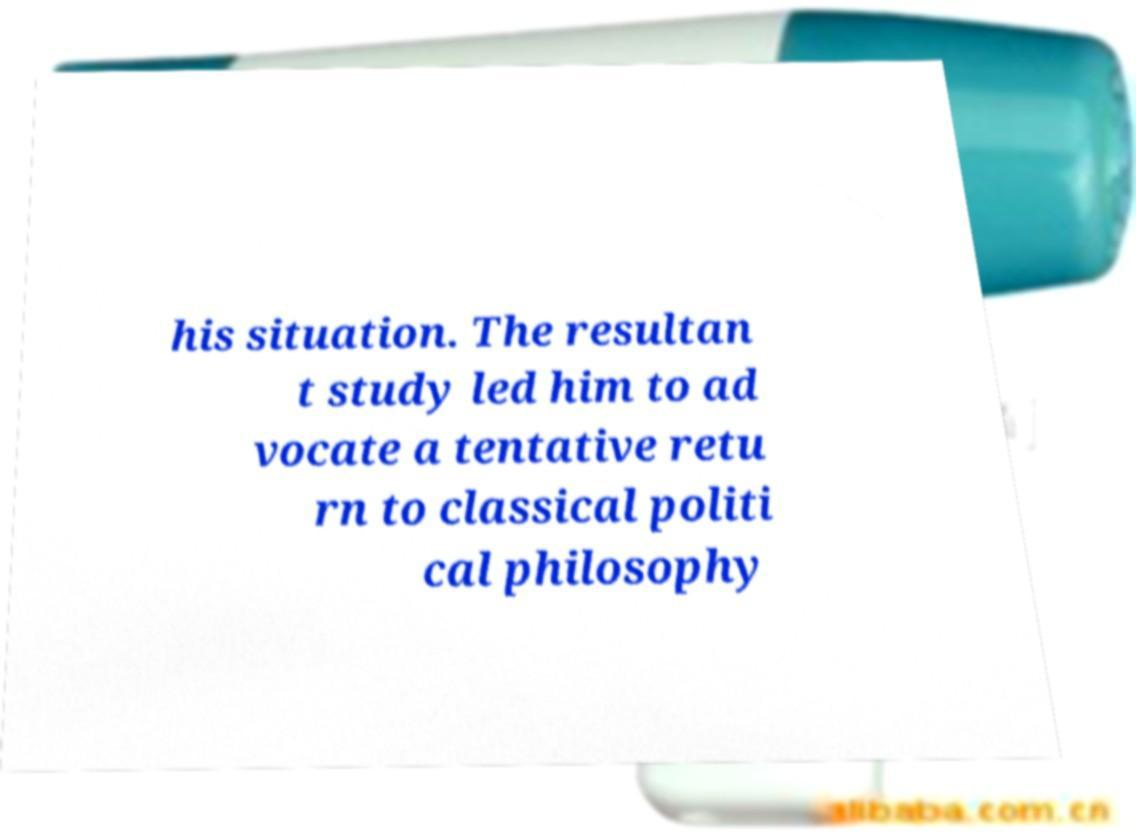I need the written content from this picture converted into text. Can you do that? his situation. The resultan t study led him to ad vocate a tentative retu rn to classical politi cal philosophy 